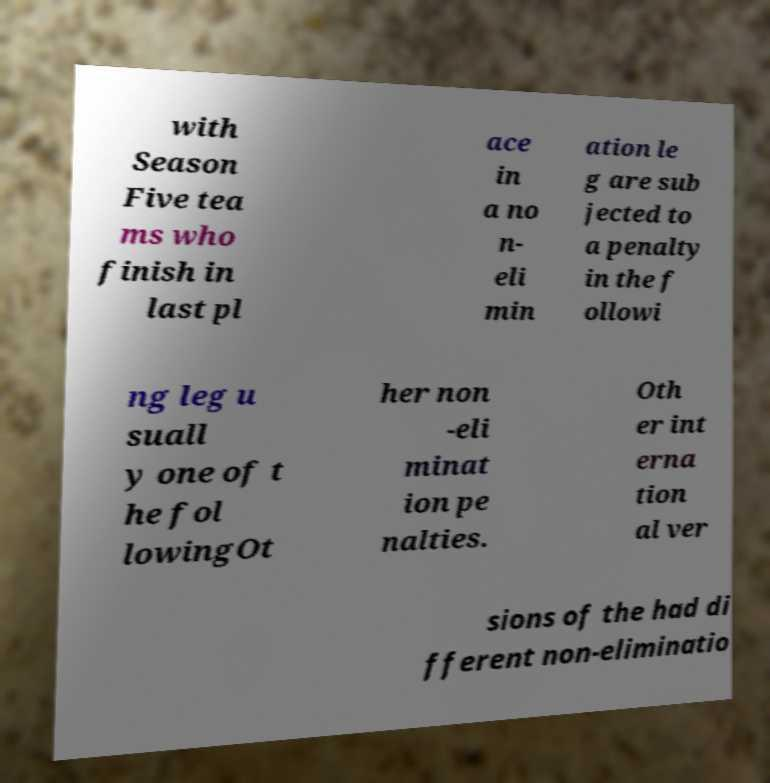Can you accurately transcribe the text from the provided image for me? with Season Five tea ms who finish in last pl ace in a no n- eli min ation le g are sub jected to a penalty in the f ollowi ng leg u suall y one of t he fol lowingOt her non -eli minat ion pe nalties. Oth er int erna tion al ver sions of the had di fferent non-eliminatio 